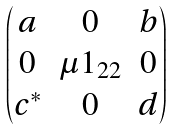Convert formula to latex. <formula><loc_0><loc_0><loc_500><loc_500>\begin{pmatrix} a & 0 & b \\ 0 & \mu 1 _ { 2 2 } & 0 \\ c ^ { * } & 0 & d \end{pmatrix}</formula> 